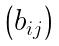Convert formula to latex. <formula><loc_0><loc_0><loc_500><loc_500>\begin{pmatrix} b _ { i j } \end{pmatrix}</formula> 